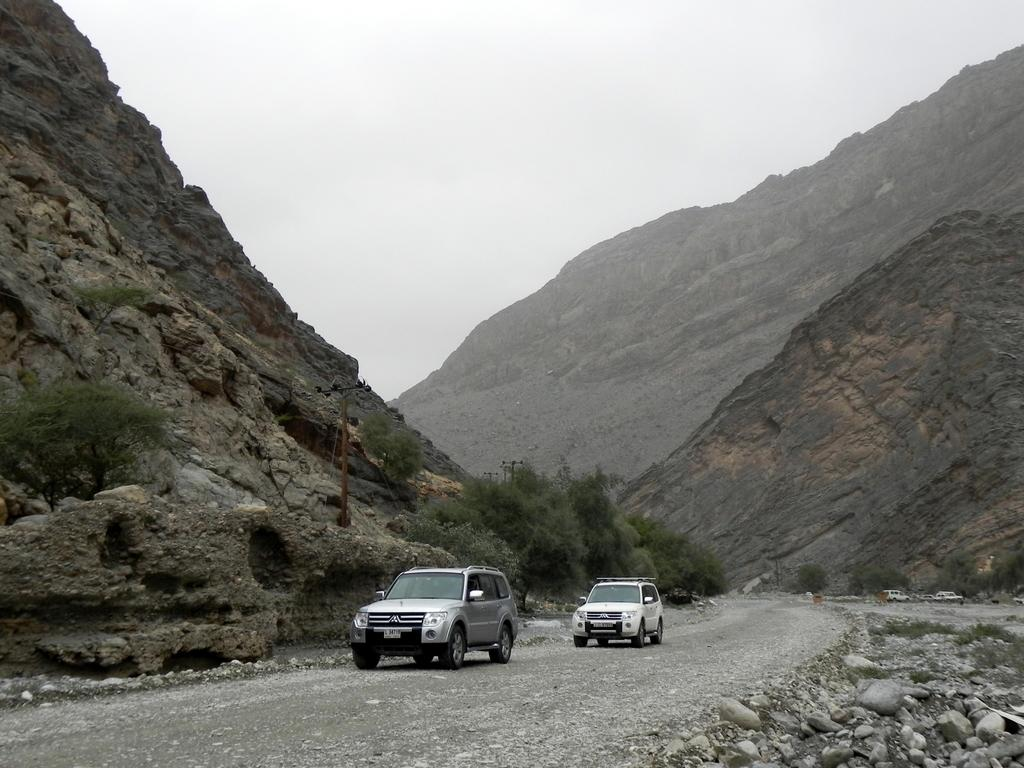What is happening on the road in the image? There are two vehicles moving on the road in the image. What can be seen in the middle of the image? There are trees in the middle of the image. What type of landscape is visible in the image? There are hills in the image. What is the condition of the sky in the image? The sky is cloudy in the image. What type of shock can be seen on the spy's face in the image? There is no spy or shock present in the image; it features two vehicles moving on a road with trees, hills, and a cloudy sky. 